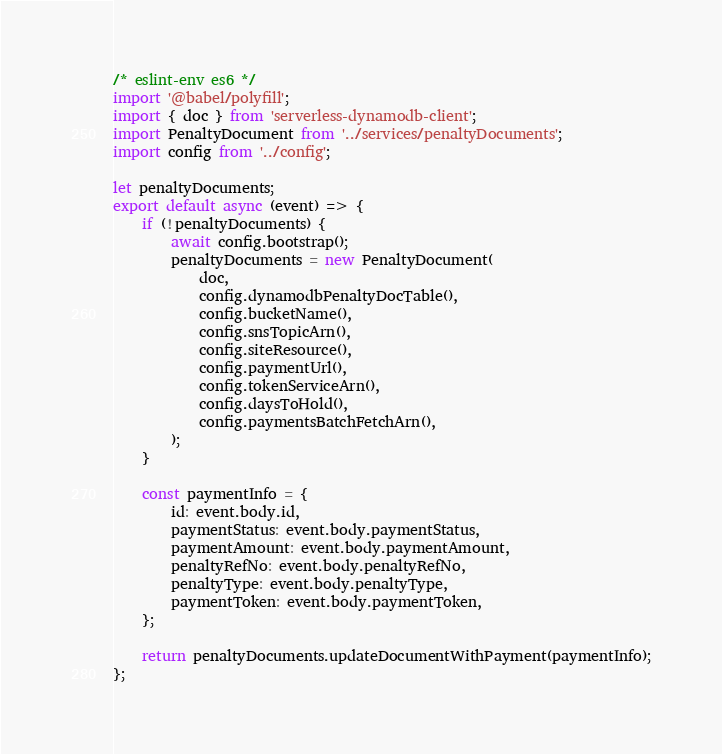Convert code to text. <code><loc_0><loc_0><loc_500><loc_500><_JavaScript_>/* eslint-env es6 */
import '@babel/polyfill';
import { doc } from 'serverless-dynamodb-client';
import PenaltyDocument from '../services/penaltyDocuments';
import config from '../config';

let penaltyDocuments;
export default async (event) => {
	if (!penaltyDocuments) {
		await config.bootstrap();
		penaltyDocuments = new PenaltyDocument(
			doc,
			config.dynamodbPenaltyDocTable(),
			config.bucketName(),
			config.snsTopicArn(),
			config.siteResource(),
			config.paymentUrl(),
			config.tokenServiceArn(),
			config.daysToHold(),
			config.paymentsBatchFetchArn(),
		);
	}

	const paymentInfo = {
		id: event.body.id,
		paymentStatus: event.body.paymentStatus,
		paymentAmount: event.body.paymentAmount,
		penaltyRefNo: event.body.penaltyRefNo,
		penaltyType: event.body.penaltyType,
		paymentToken: event.body.paymentToken,
	};

	return penaltyDocuments.updateDocumentWithPayment(paymentInfo);
};
</code> 